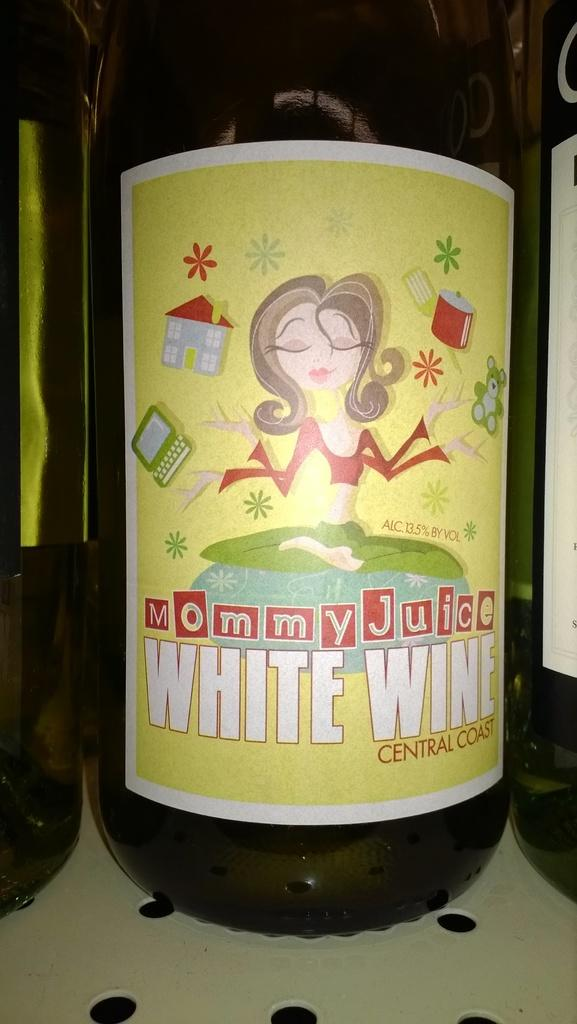<image>
Provide a brief description of the given image. a bottle of mommy juice white wine central coast 